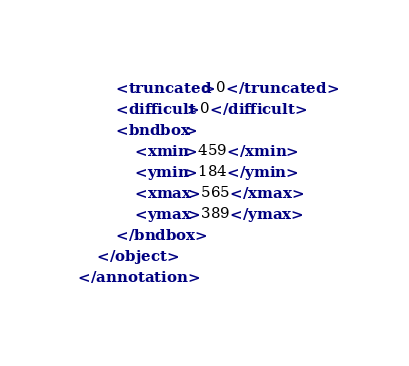<code> <loc_0><loc_0><loc_500><loc_500><_XML_>		<truncated>0</truncated>
		<difficult>0</difficult>
		<bndbox>
			<xmin>459</xmin>
			<ymin>184</ymin>
			<xmax>565</xmax>
			<ymax>389</ymax>
		</bndbox>
	</object>
</annotation>
</code> 